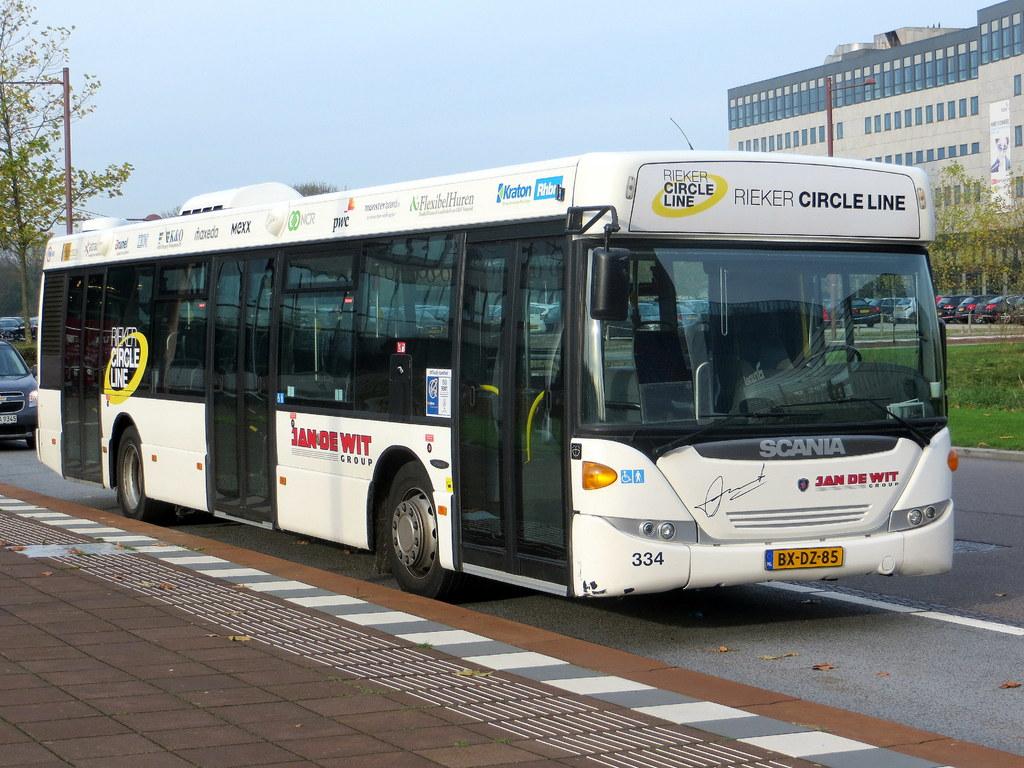What circle line is this?
Provide a short and direct response. Rieker. What does the number plate read?
Your response must be concise. Bx-dz-85. 